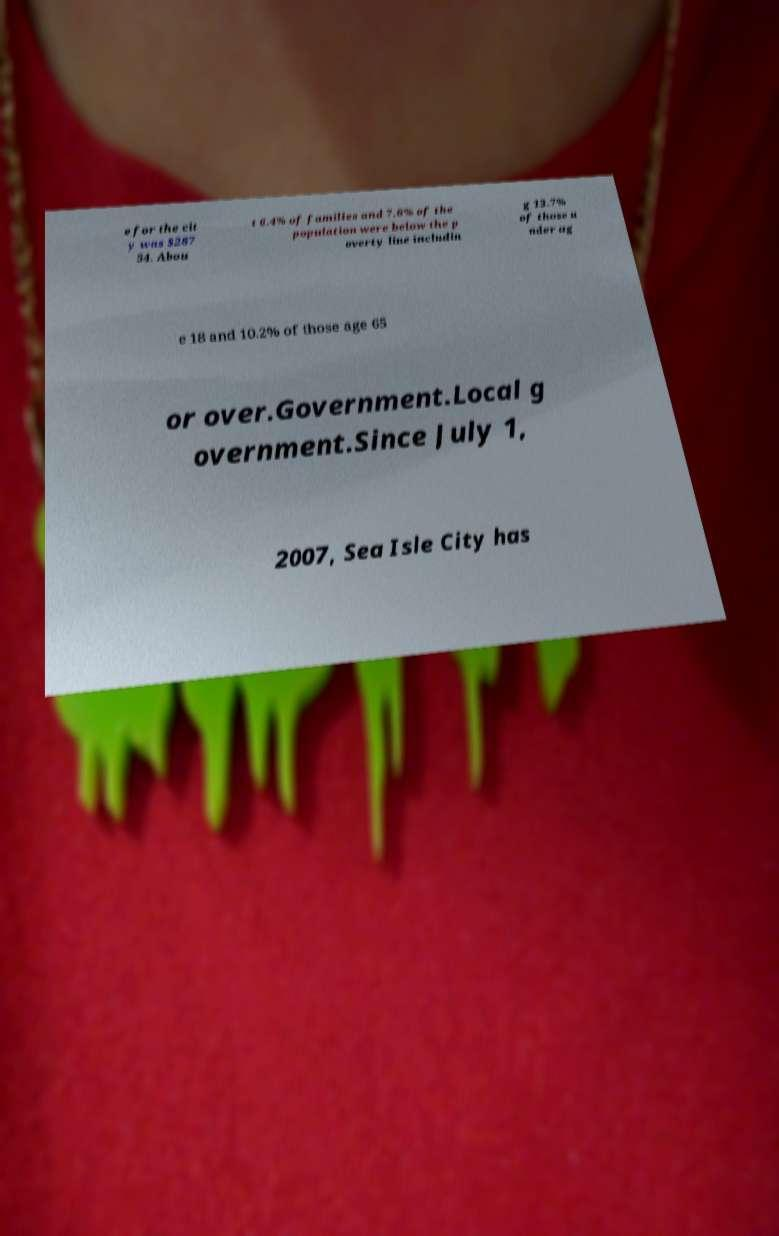What messages or text are displayed in this image? I need them in a readable, typed format. e for the cit y was $287 54. Abou t 6.4% of families and 7.6% of the population were below the p overty line includin g 13.7% of those u nder ag e 18 and 10.2% of those age 65 or over.Government.Local g overnment.Since July 1, 2007, Sea Isle City has 